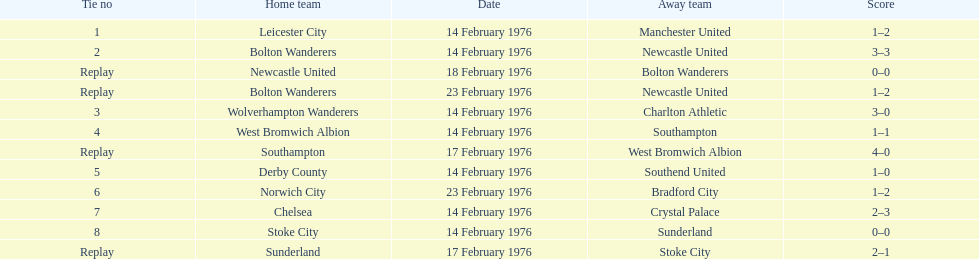What was the goal difference in the game on february 18th? 0. 